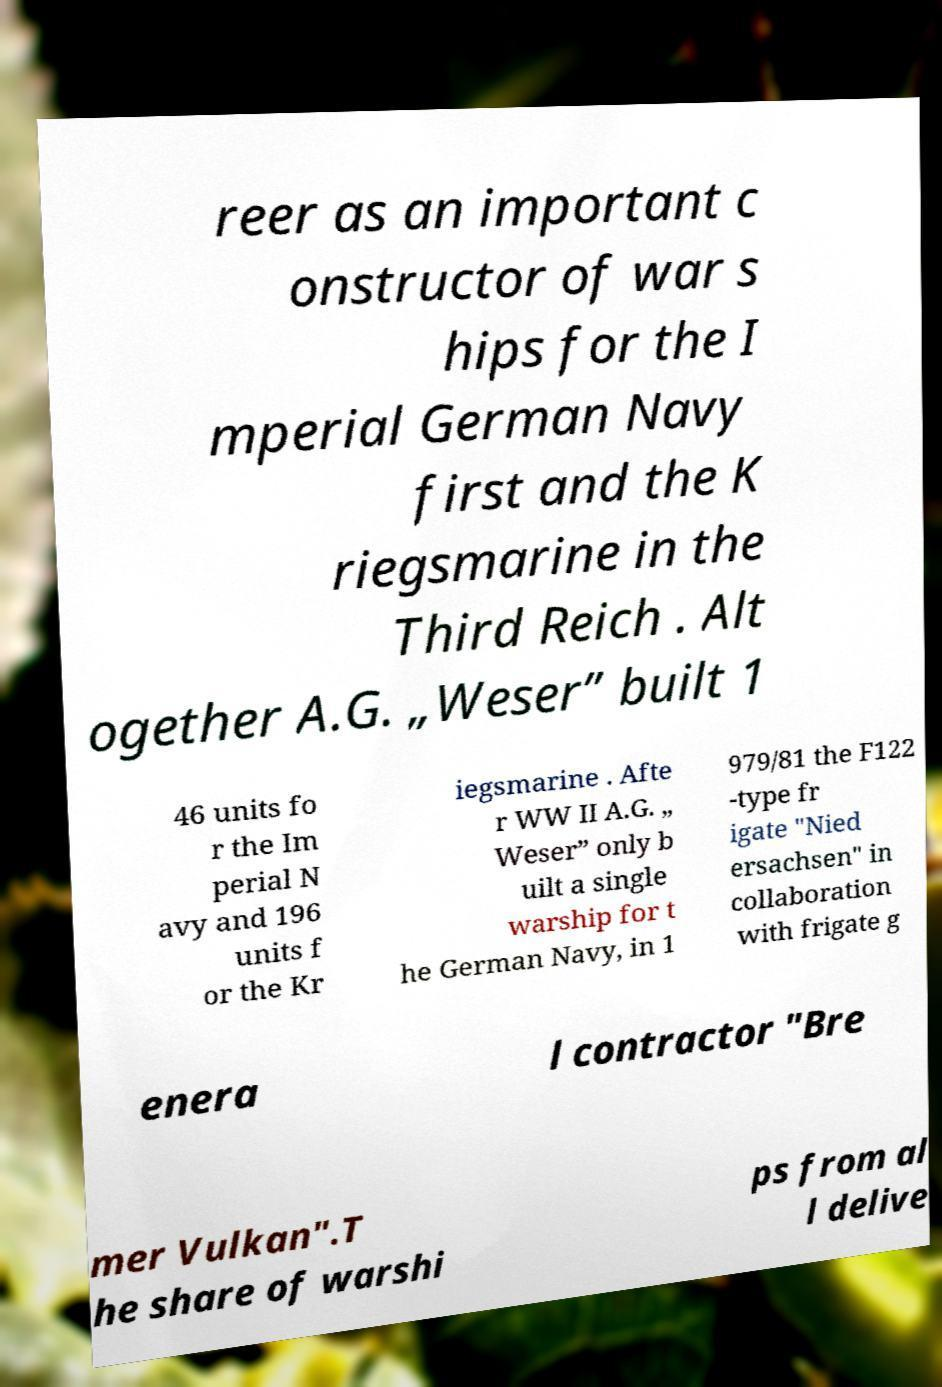For documentation purposes, I need the text within this image transcribed. Could you provide that? reer as an important c onstructor of war s hips for the I mperial German Navy first and the K riegsmarine in the Third Reich . Alt ogether A.G. „Weser” built 1 46 units fo r the Im perial N avy and 196 units f or the Kr iegsmarine . Afte r WW II A.G. „ Weser” only b uilt a single warship for t he German Navy, in 1 979/81 the F122 -type fr igate "Nied ersachsen" in collaboration with frigate g enera l contractor "Bre mer Vulkan".T he share of warshi ps from al l delive 